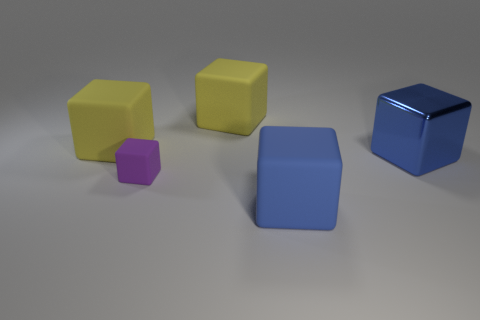Subtract all purple blocks. How many blocks are left? 4 Subtract all tiny purple matte blocks. How many blocks are left? 4 Subtract all red blocks. Subtract all gray spheres. How many blocks are left? 5 Add 5 green rubber cylinders. How many objects exist? 10 Subtract all green rubber spheres. Subtract all tiny purple matte things. How many objects are left? 4 Add 4 large blue matte things. How many large blue matte things are left? 5 Add 2 large purple blocks. How many large purple blocks exist? 2 Subtract 0 purple balls. How many objects are left? 5 